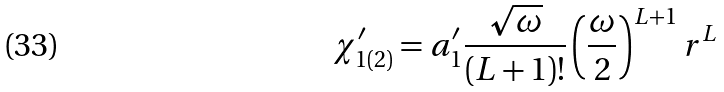<formula> <loc_0><loc_0><loc_500><loc_500>\chi ^ { \prime } _ { 1 ( 2 ) } = a ^ { \prime } _ { 1 } \frac { \sqrt { \omega } } { ( L + 1 ) ! } \left ( \frac { \omega } { 2 } \right ) ^ { L + 1 } r ^ { L }</formula> 